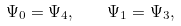Convert formula to latex. <formula><loc_0><loc_0><loc_500><loc_500>\Psi _ { 0 } = \Psi _ { 4 } , \quad \Psi _ { 1 } = \Psi _ { 3 } ,</formula> 